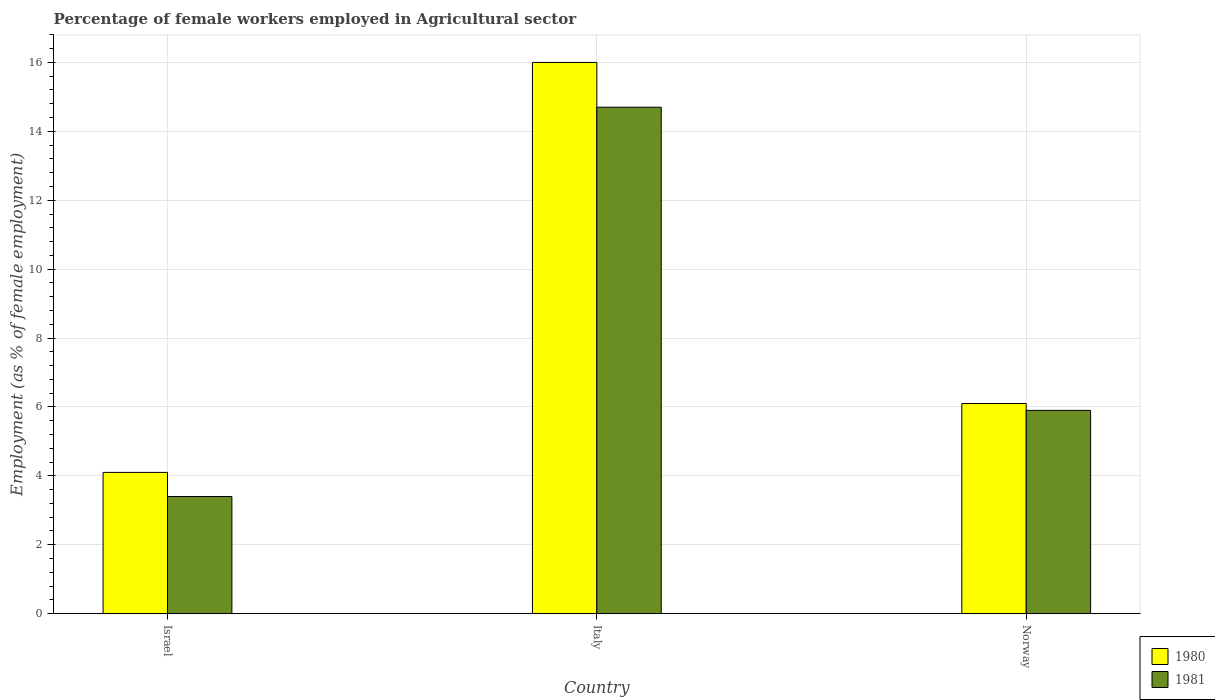Are the number of bars per tick equal to the number of legend labels?
Your answer should be compact. Yes. How many bars are there on the 1st tick from the left?
Give a very brief answer. 2. What is the percentage of females employed in Agricultural sector in 1980 in Israel?
Your answer should be compact. 4.1. Across all countries, what is the maximum percentage of females employed in Agricultural sector in 1981?
Offer a very short reply. 14.7. Across all countries, what is the minimum percentage of females employed in Agricultural sector in 1981?
Offer a terse response. 3.4. In which country was the percentage of females employed in Agricultural sector in 1981 maximum?
Provide a short and direct response. Italy. In which country was the percentage of females employed in Agricultural sector in 1980 minimum?
Your answer should be very brief. Israel. What is the total percentage of females employed in Agricultural sector in 1980 in the graph?
Provide a succinct answer. 26.2. What is the difference between the percentage of females employed in Agricultural sector in 1980 in Israel and that in Italy?
Keep it short and to the point. -11.9. What is the difference between the percentage of females employed in Agricultural sector in 1981 in Norway and the percentage of females employed in Agricultural sector in 1980 in Italy?
Keep it short and to the point. -10.1. What is the average percentage of females employed in Agricultural sector in 1981 per country?
Your answer should be compact. 8. What is the difference between the percentage of females employed in Agricultural sector of/in 1980 and percentage of females employed in Agricultural sector of/in 1981 in Norway?
Ensure brevity in your answer.  0.2. In how many countries, is the percentage of females employed in Agricultural sector in 1981 greater than 7.2 %?
Offer a very short reply. 1. What is the ratio of the percentage of females employed in Agricultural sector in 1981 in Israel to that in Italy?
Your answer should be compact. 0.23. Is the percentage of females employed in Agricultural sector in 1980 in Italy less than that in Norway?
Ensure brevity in your answer.  No. What is the difference between the highest and the second highest percentage of females employed in Agricultural sector in 1981?
Make the answer very short. -2.5. What is the difference between the highest and the lowest percentage of females employed in Agricultural sector in 1980?
Make the answer very short. 11.9. In how many countries, is the percentage of females employed in Agricultural sector in 1980 greater than the average percentage of females employed in Agricultural sector in 1980 taken over all countries?
Your answer should be very brief. 1. Is the sum of the percentage of females employed in Agricultural sector in 1981 in Italy and Norway greater than the maximum percentage of females employed in Agricultural sector in 1980 across all countries?
Provide a short and direct response. Yes. How many bars are there?
Your response must be concise. 6. What is the difference between two consecutive major ticks on the Y-axis?
Make the answer very short. 2. Does the graph contain grids?
Provide a succinct answer. Yes. Where does the legend appear in the graph?
Offer a terse response. Bottom right. How many legend labels are there?
Ensure brevity in your answer.  2. How are the legend labels stacked?
Your answer should be compact. Vertical. What is the title of the graph?
Your answer should be compact. Percentage of female workers employed in Agricultural sector. Does "1993" appear as one of the legend labels in the graph?
Provide a short and direct response. No. What is the label or title of the X-axis?
Offer a very short reply. Country. What is the label or title of the Y-axis?
Your response must be concise. Employment (as % of female employment). What is the Employment (as % of female employment) of 1980 in Israel?
Offer a very short reply. 4.1. What is the Employment (as % of female employment) of 1981 in Israel?
Your answer should be very brief. 3.4. What is the Employment (as % of female employment) of 1981 in Italy?
Your answer should be very brief. 14.7. What is the Employment (as % of female employment) in 1980 in Norway?
Keep it short and to the point. 6.1. What is the Employment (as % of female employment) in 1981 in Norway?
Ensure brevity in your answer.  5.9. Across all countries, what is the maximum Employment (as % of female employment) in 1981?
Keep it short and to the point. 14.7. Across all countries, what is the minimum Employment (as % of female employment) in 1980?
Offer a terse response. 4.1. Across all countries, what is the minimum Employment (as % of female employment) in 1981?
Provide a succinct answer. 3.4. What is the total Employment (as % of female employment) of 1980 in the graph?
Your answer should be compact. 26.2. What is the total Employment (as % of female employment) of 1981 in the graph?
Offer a very short reply. 24. What is the difference between the Employment (as % of female employment) in 1980 in Israel and that in Italy?
Provide a short and direct response. -11.9. What is the difference between the Employment (as % of female employment) in 1981 in Israel and that in Italy?
Make the answer very short. -11.3. What is the difference between the Employment (as % of female employment) in 1980 in Israel and the Employment (as % of female employment) in 1981 in Italy?
Your answer should be very brief. -10.6. What is the difference between the Employment (as % of female employment) of 1980 in Italy and the Employment (as % of female employment) of 1981 in Norway?
Your answer should be very brief. 10.1. What is the average Employment (as % of female employment) in 1980 per country?
Provide a succinct answer. 8.73. What is the average Employment (as % of female employment) in 1981 per country?
Provide a succinct answer. 8. What is the difference between the Employment (as % of female employment) in 1980 and Employment (as % of female employment) in 1981 in Italy?
Your response must be concise. 1.3. What is the ratio of the Employment (as % of female employment) of 1980 in Israel to that in Italy?
Your response must be concise. 0.26. What is the ratio of the Employment (as % of female employment) of 1981 in Israel to that in Italy?
Provide a short and direct response. 0.23. What is the ratio of the Employment (as % of female employment) of 1980 in Israel to that in Norway?
Offer a terse response. 0.67. What is the ratio of the Employment (as % of female employment) in 1981 in Israel to that in Norway?
Ensure brevity in your answer.  0.58. What is the ratio of the Employment (as % of female employment) in 1980 in Italy to that in Norway?
Offer a very short reply. 2.62. What is the ratio of the Employment (as % of female employment) of 1981 in Italy to that in Norway?
Give a very brief answer. 2.49. What is the difference between the highest and the lowest Employment (as % of female employment) of 1980?
Your response must be concise. 11.9. What is the difference between the highest and the lowest Employment (as % of female employment) in 1981?
Give a very brief answer. 11.3. 